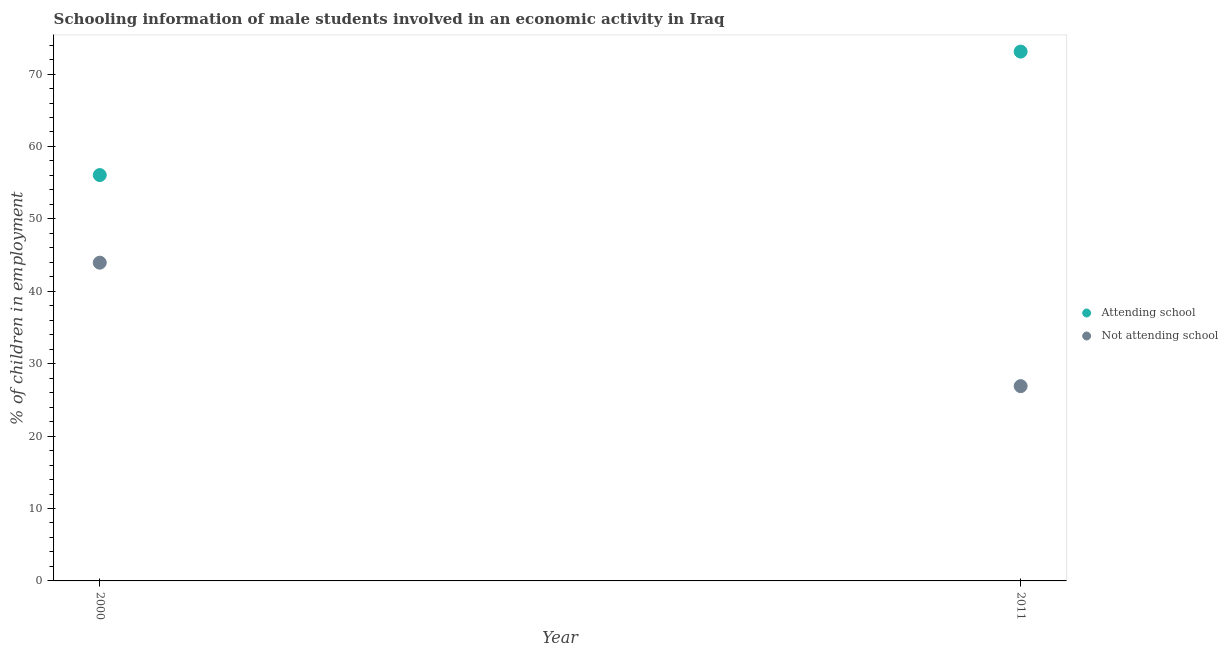How many different coloured dotlines are there?
Your response must be concise. 2. Is the number of dotlines equal to the number of legend labels?
Offer a terse response. Yes. What is the percentage of employed males who are not attending school in 2000?
Give a very brief answer. 43.95. Across all years, what is the maximum percentage of employed males who are not attending school?
Ensure brevity in your answer.  43.95. Across all years, what is the minimum percentage of employed males who are attending school?
Make the answer very short. 56.05. In which year was the percentage of employed males who are not attending school minimum?
Offer a terse response. 2011. What is the total percentage of employed males who are attending school in the graph?
Your response must be concise. 129.15. What is the difference between the percentage of employed males who are attending school in 2000 and that in 2011?
Offer a very short reply. -17.05. What is the difference between the percentage of employed males who are attending school in 2011 and the percentage of employed males who are not attending school in 2000?
Your answer should be compact. 29.15. What is the average percentage of employed males who are attending school per year?
Your response must be concise. 64.58. In the year 2000, what is the difference between the percentage of employed males who are attending school and percentage of employed males who are not attending school?
Your response must be concise. 12.1. What is the ratio of the percentage of employed males who are not attending school in 2000 to that in 2011?
Give a very brief answer. 1.63. How many dotlines are there?
Your answer should be compact. 2. How many years are there in the graph?
Your answer should be very brief. 2. What is the difference between two consecutive major ticks on the Y-axis?
Your answer should be compact. 10. Does the graph contain grids?
Offer a very short reply. No. What is the title of the graph?
Make the answer very short. Schooling information of male students involved in an economic activity in Iraq. Does "Research and Development" appear as one of the legend labels in the graph?
Offer a very short reply. No. What is the label or title of the Y-axis?
Provide a succinct answer. % of children in employment. What is the % of children in employment of Attending school in 2000?
Provide a succinct answer. 56.05. What is the % of children in employment of Not attending school in 2000?
Your answer should be very brief. 43.95. What is the % of children in employment in Attending school in 2011?
Your response must be concise. 73.1. What is the % of children in employment of Not attending school in 2011?
Make the answer very short. 26.9. Across all years, what is the maximum % of children in employment of Attending school?
Provide a succinct answer. 73.1. Across all years, what is the maximum % of children in employment of Not attending school?
Your response must be concise. 43.95. Across all years, what is the minimum % of children in employment of Attending school?
Ensure brevity in your answer.  56.05. Across all years, what is the minimum % of children in employment in Not attending school?
Keep it short and to the point. 26.9. What is the total % of children in employment of Attending school in the graph?
Provide a short and direct response. 129.15. What is the total % of children in employment in Not attending school in the graph?
Your answer should be compact. 70.85. What is the difference between the % of children in employment in Attending school in 2000 and that in 2011?
Offer a terse response. -17.05. What is the difference between the % of children in employment in Not attending school in 2000 and that in 2011?
Offer a terse response. 17.05. What is the difference between the % of children in employment in Attending school in 2000 and the % of children in employment in Not attending school in 2011?
Your answer should be very brief. 29.15. What is the average % of children in employment of Attending school per year?
Offer a very short reply. 64.58. What is the average % of children in employment of Not attending school per year?
Your answer should be very brief. 35.42. In the year 2000, what is the difference between the % of children in employment of Attending school and % of children in employment of Not attending school?
Your answer should be very brief. 12.1. In the year 2011, what is the difference between the % of children in employment of Attending school and % of children in employment of Not attending school?
Provide a short and direct response. 46.2. What is the ratio of the % of children in employment in Attending school in 2000 to that in 2011?
Give a very brief answer. 0.77. What is the ratio of the % of children in employment in Not attending school in 2000 to that in 2011?
Make the answer very short. 1.63. What is the difference between the highest and the second highest % of children in employment in Attending school?
Give a very brief answer. 17.05. What is the difference between the highest and the second highest % of children in employment in Not attending school?
Give a very brief answer. 17.05. What is the difference between the highest and the lowest % of children in employment in Attending school?
Your answer should be compact. 17.05. What is the difference between the highest and the lowest % of children in employment in Not attending school?
Your answer should be compact. 17.05. 